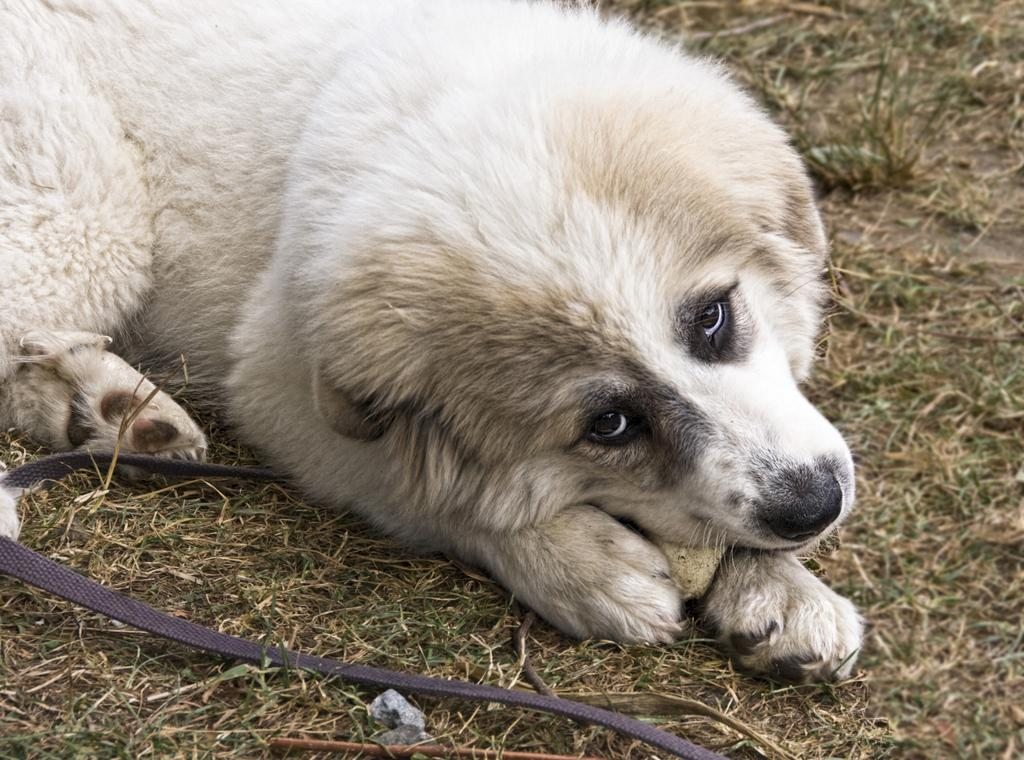What animal can be seen in the image? There is a dog in the image. What is the dog doing in the image? The dog is lying on the ground. What other object can be seen on the ground in the image? There is a belt on the ground. Are there any other objects visible on the ground in the image? Yes, there are other objects on the ground. What type of wool can be seen in the image? There is no wool present in the image. How does the dog use the spoon in the image? There is no spoon present in the image. 